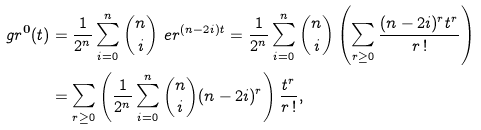<formula> <loc_0><loc_0><loc_500><loc_500>\ g r ^ { \mathbf 0 } ( t ) & = \frac { 1 } { 2 ^ { n } } \sum _ { i = 0 } ^ { n } { n \choose i } \ e r ^ { ( n - 2 i ) t } = \frac { 1 } { 2 ^ { n } } \sum _ { i = 0 } ^ { n } { n \choose i } \left ( \sum _ { r \geq 0 } \frac { ( n - 2 i ) ^ { r } t ^ { r } } { r \, ! } \right ) \\ & = \sum _ { r \geq 0 } \left ( \frac { 1 } { 2 ^ { n } } \sum _ { i = 0 } ^ { n } { n \choose i } ( n - 2 i ) ^ { r } \right ) \frac { t ^ { r } } { r \, ! } ,</formula> 